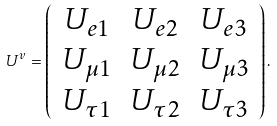Convert formula to latex. <formula><loc_0><loc_0><loc_500><loc_500>U ^ { v } = \left ( \begin{array} { c c c } U _ { e 1 } & U _ { e 2 } & U _ { e 3 } \\ U _ { \mu 1 } & U _ { \mu 2 } & U _ { \mu 3 } \\ U _ { \tau 1 } & U _ { \tau 2 } & U _ { \tau 3 } \end{array} \right ) .</formula> 